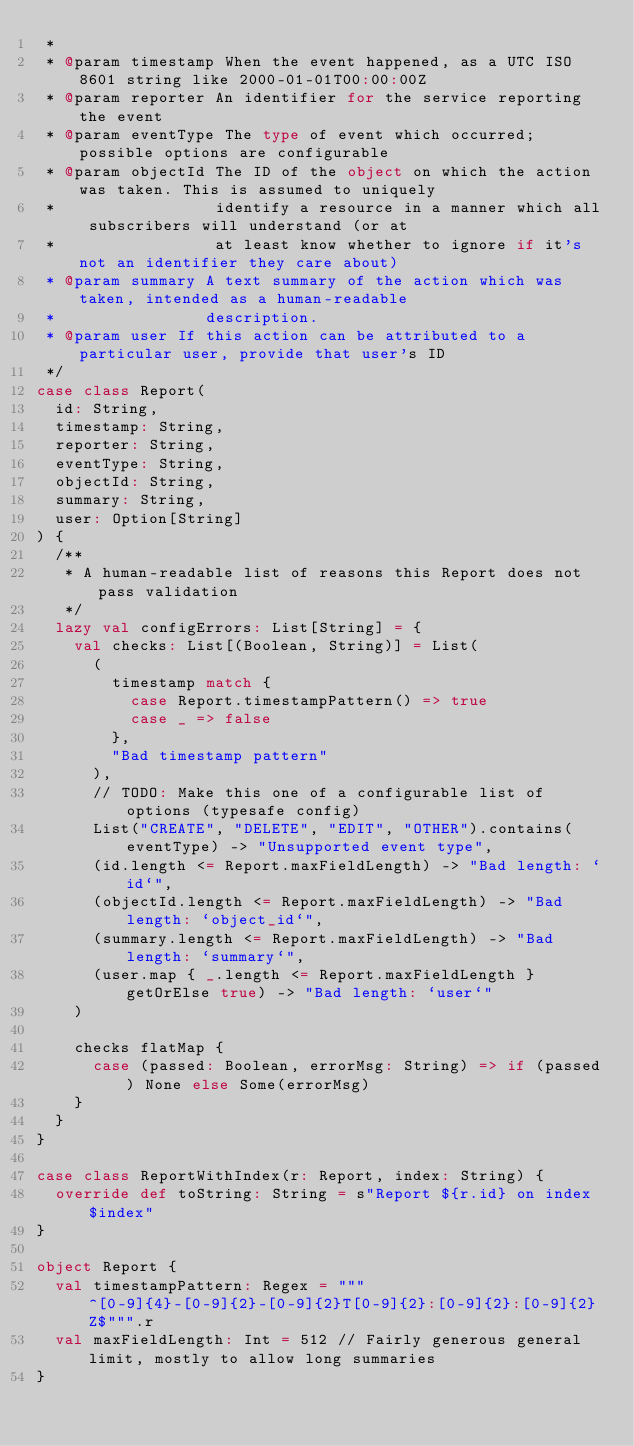Convert code to text. <code><loc_0><loc_0><loc_500><loc_500><_Scala_> *
 * @param timestamp When the event happened, as a UTC ISO 8601 string like 2000-01-01T00:00:00Z
 * @param reporter An identifier for the service reporting the event
 * @param eventType The type of event which occurred; possible options are configurable
 * @param objectId The ID of the object on which the action was taken. This is assumed to uniquely
 *                 identify a resource in a manner which all subscribers will understand (or at
 *                 at least know whether to ignore if it's not an identifier they care about)
 * @param summary A text summary of the action which was taken, intended as a human-readable
 *                description.
 * @param user If this action can be attributed to a particular user, provide that user's ID
 */
case class Report(
  id: String,
  timestamp: String,
  reporter: String,
  eventType: String,
  objectId: String,
  summary: String,
  user: Option[String]
) {
  /**
   * A human-readable list of reasons this Report does not pass validation
   */
  lazy val configErrors: List[String] = {
    val checks: List[(Boolean, String)] = List(
      (
        timestamp match {
          case Report.timestampPattern() => true
          case _ => false
        },
        "Bad timestamp pattern"
      ),
      // TODO: Make this one of a configurable list of options (typesafe config)
      List("CREATE", "DELETE", "EDIT", "OTHER").contains(eventType) -> "Unsupported event type",
      (id.length <= Report.maxFieldLength) -> "Bad length: `id`",
      (objectId.length <= Report.maxFieldLength) -> "Bad length: `object_id`",
      (summary.length <= Report.maxFieldLength) -> "Bad length: `summary`",
      (user.map { _.length <= Report.maxFieldLength } getOrElse true) -> "Bad length: `user`"
    )

    checks flatMap {
      case (passed: Boolean, errorMsg: String) => if (passed) None else Some(errorMsg)
    }
  }
}

case class ReportWithIndex(r: Report, index: String) {
  override def toString: String = s"Report ${r.id} on index $index"
}

object Report {
  val timestampPattern: Regex = """^[0-9]{4}-[0-9]{2}-[0-9]{2}T[0-9]{2}:[0-9]{2}:[0-9]{2}Z$""".r
  val maxFieldLength: Int = 512 // Fairly generous general limit, mostly to allow long summaries
}
</code> 